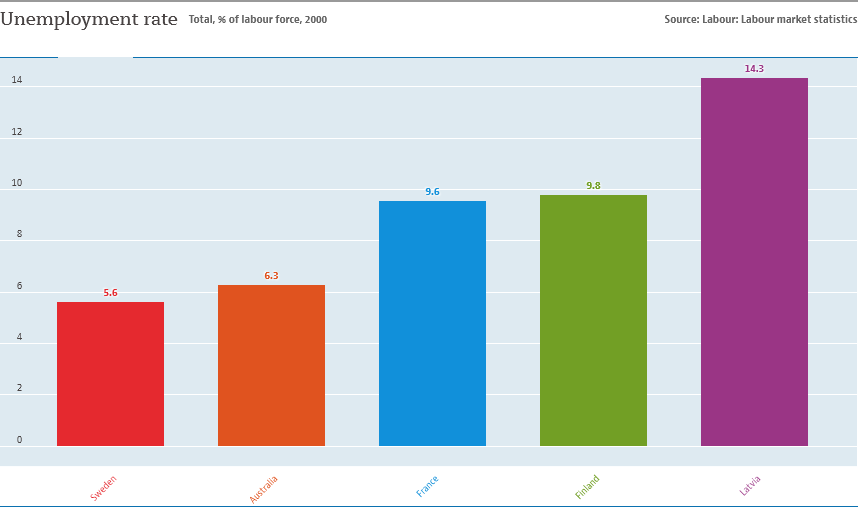Give some essential details in this illustration. The sum of the smallest two bars is not greater than the value of the largest bar. The value of the longest bar is 14.3. 